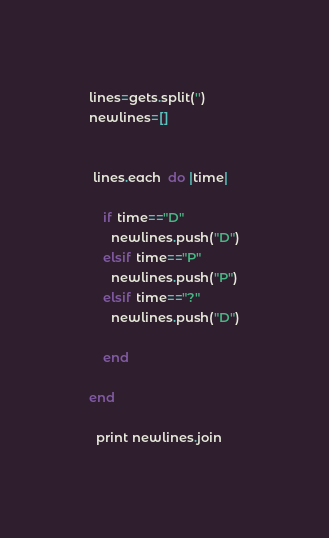Convert code to text. <code><loc_0><loc_0><loc_500><loc_500><_Ruby_>lines=gets.split('')
newlines=[]


 lines.each  do |time|
    
  	if time=="D"
      newlines.push("D")
 	elsif time=="P"   		
      newlines.push("P")
    elsif time=="?"
      newlines.push("D")
 	
	end
 
end

  print newlines.join
</code> 